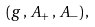Convert formula to latex. <formula><loc_0><loc_0><loc_500><loc_500>( g \, , \, A _ { + } \, , \, A _ { - } ) \, ,</formula> 